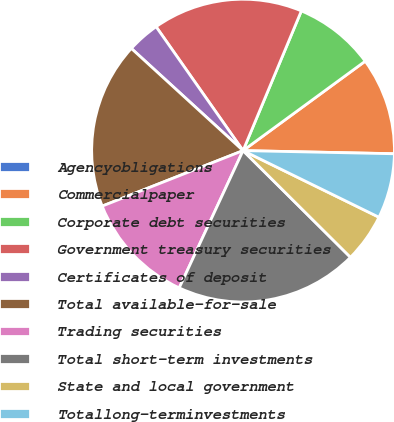Convert chart. <chart><loc_0><loc_0><loc_500><loc_500><pie_chart><fcel>Agencyobligations<fcel>Commercialpaper<fcel>Corporate debt securities<fcel>Government treasury securities<fcel>Certificates of deposit<fcel>Total available-for-sale<fcel>Trading securities<fcel>Total short-term investments<fcel>State and local government<fcel>Totallong-terminvestments<nl><fcel>0.01%<fcel>10.38%<fcel>8.65%<fcel>16.03%<fcel>3.47%<fcel>17.76%<fcel>12.1%<fcel>19.48%<fcel>5.19%<fcel>6.92%<nl></chart> 